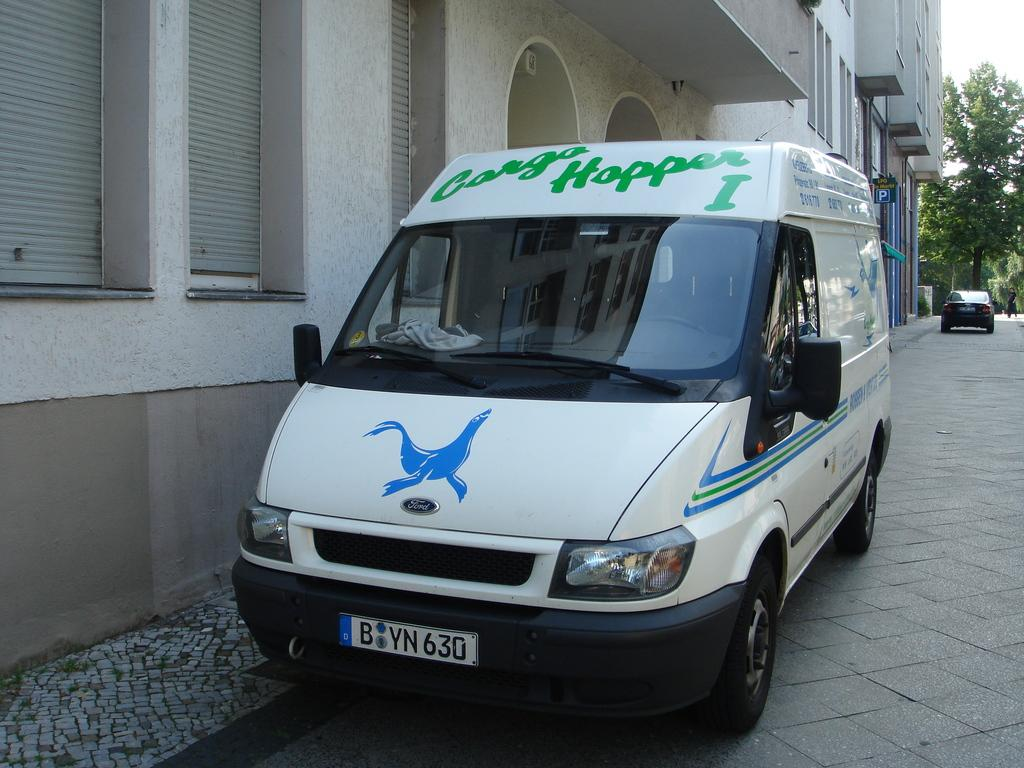Provide a one-sentence caption for the provided image. A white van on a street with a blue seal on the front and Cargo Hopper 1 written in green above the front windshield. 